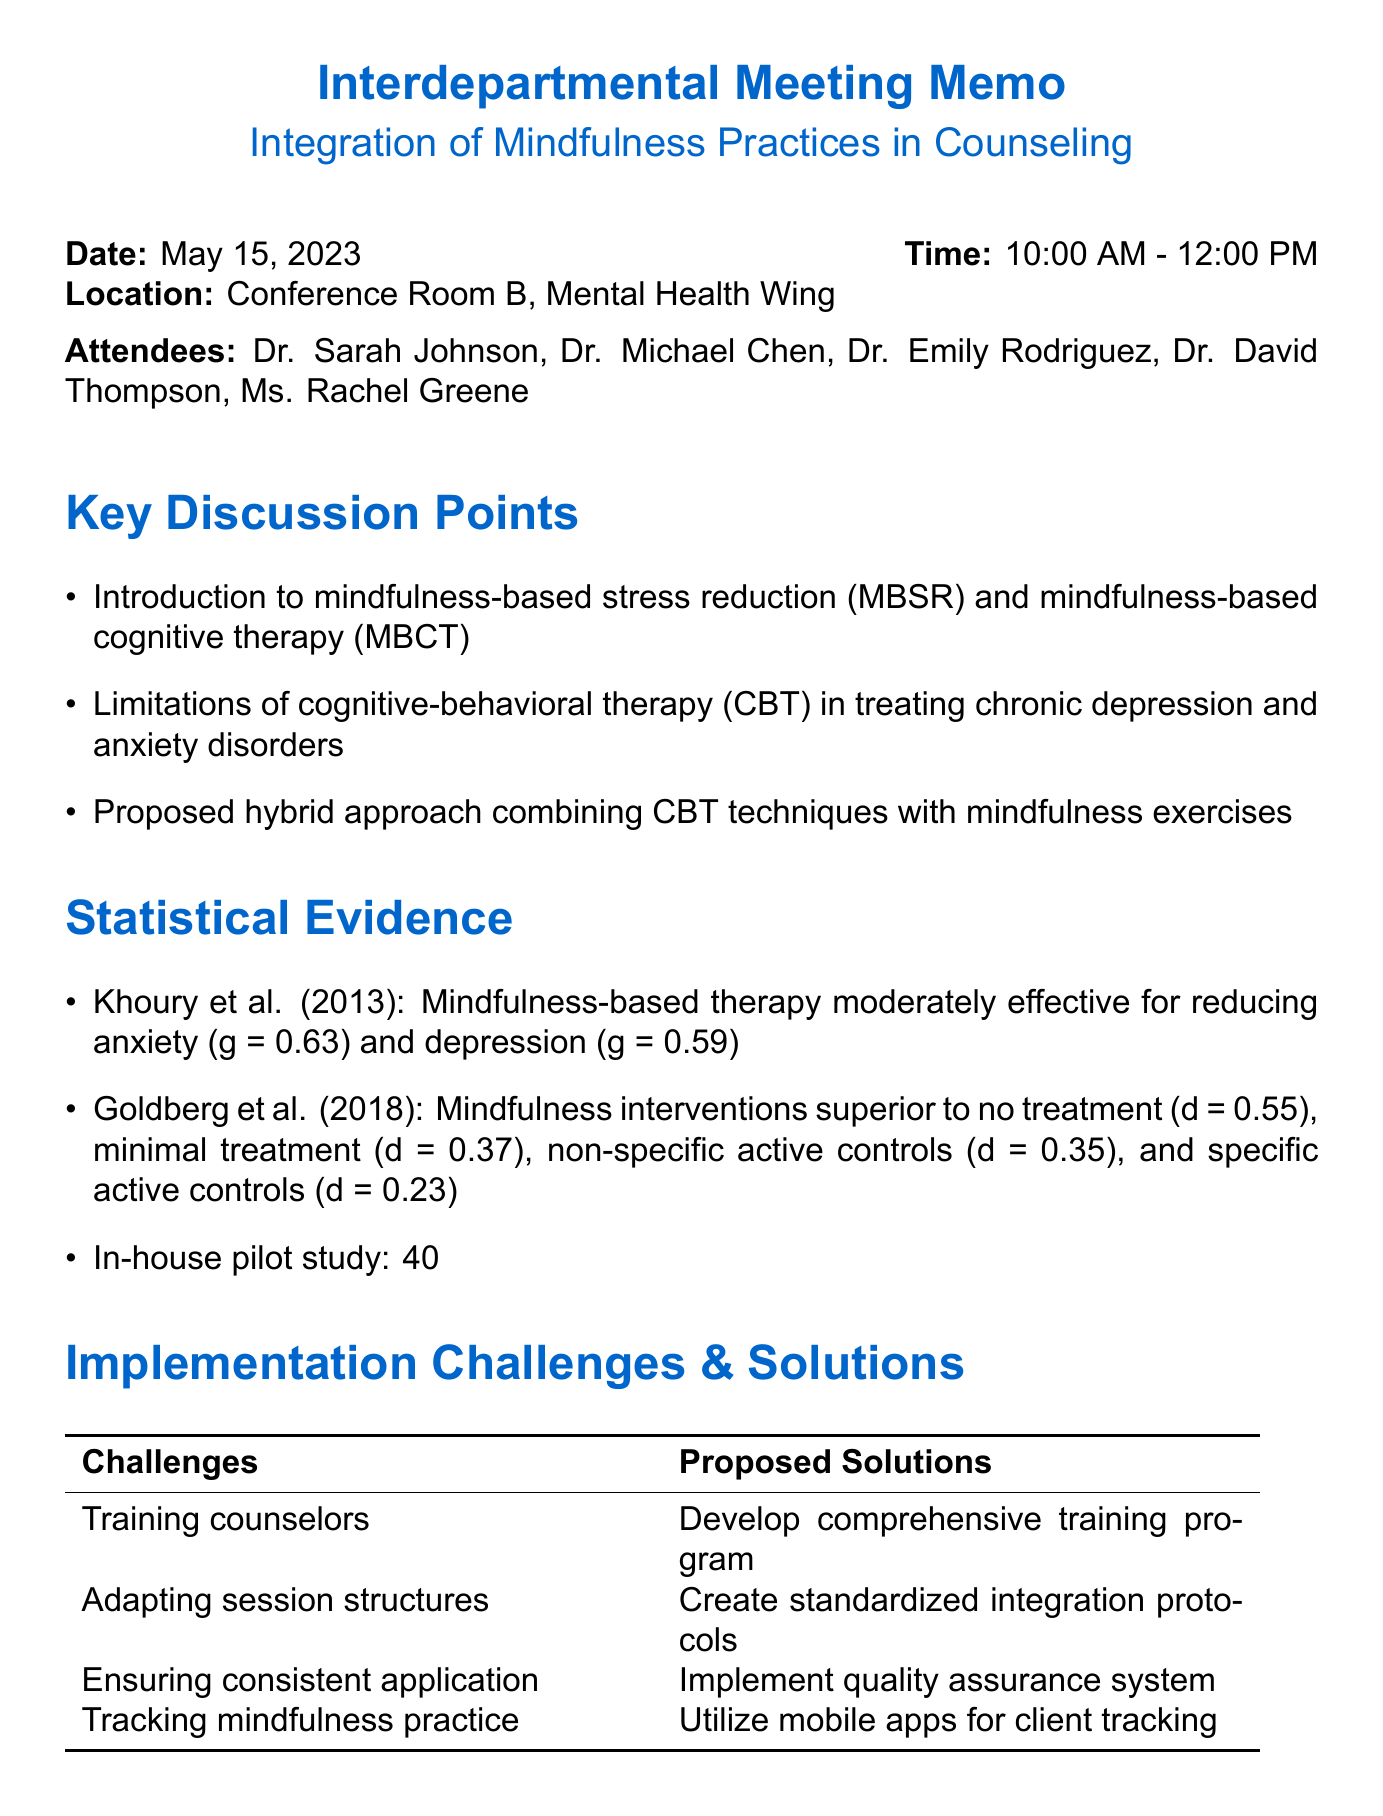What is the date of the meeting? The meeting is scheduled for May 15, 2023, as indicated in the document.
Answer: May 15, 2023 Who proposed designing integration protocols? The document specifies Dr. Chen and Ms. Greene as the assignees for designing integration protocols.
Answer: Dr. Chen and Ms. Greene What statistical evidence indicates the effectiveness of mindfulness practices? The evidence from the in-house pilot study shows a 40% greater reduction in anxiety symptoms with integrated mindfulness and CBT.
Answer: 40% What was discussed regarding the limitations of traditional approaches? Dr. Chen highlighted the limitations of cognitive-behavioral therapy in treating chronic depression and anxiety disorders.
Answer: Limitations of cognitive-behavioral therapy When is the next meeting scheduled? The document states that the next meeting is on August 1, 2023.
Answer: August 1, 2023 What training program will be developed? The document mentions developing a comprehensive training program for counselors as a proposed solution.
Answer: Comprehensive training program What finding was presented by Khoury et al. (2013)? This study found that mindfulness-based therapy was moderately effective for reducing anxiety and depression symptoms.
Answer: Moderately effective What is one of the implementation challenges mentioned? The document lists training counselors in mindfulness techniques as one of the implementation challenges.
Answer: Training counselors in mindfulness techniques 